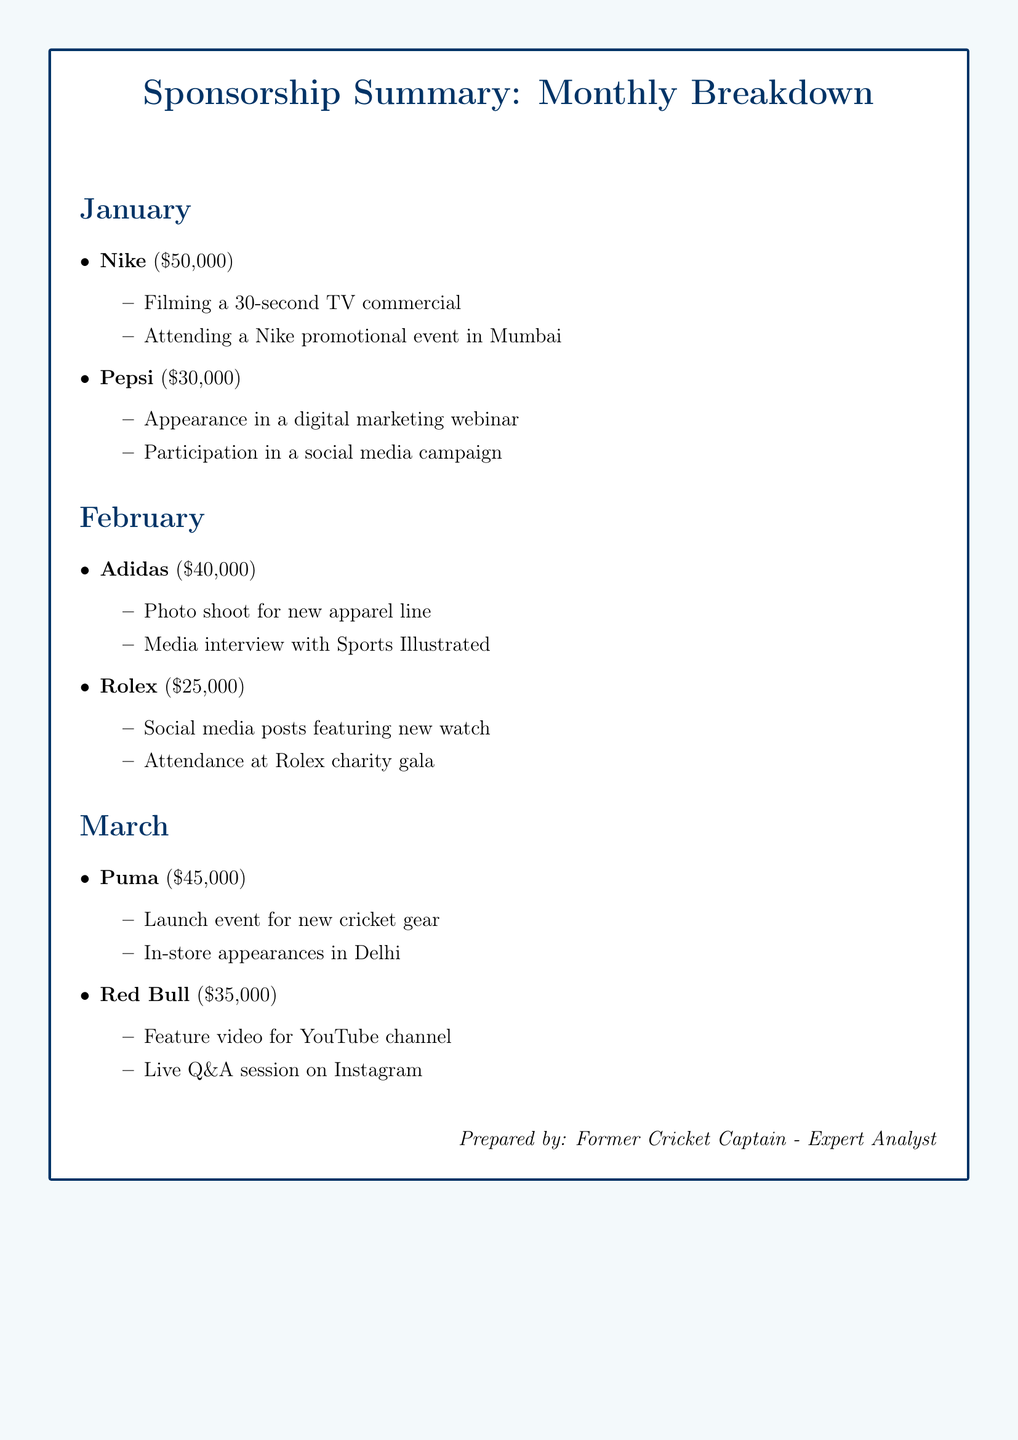What is the sponsorship amount from Nike in January? The document states that Nike's sponsorship amount in January is \$50,000.
Answer: \$50,000 Which company had endorsements worth \$40,000 in February? According to the document, Adidas had endorsements worth \$40,000 in February.
Answer: Adidas How many events did Pepsi sponsor in January? The document mentions two events sponsored by Pepsi in January: a digital marketing webinar and a social media campaign.
Answer: 2 What was the total endorsement income for March? The total for March is calculated as \$45,000 (Puma) + \$35,000 (Red Bull) = \$80,000.
Answer: \$80,000 What type of event did Rolex sponsor in February? The document mentions that Rolex sponsored a charity gala in February.
Answer: Charity gala Which months featured Puma as a sponsor? Puma is listed as a sponsor only in March according to the document.
Answer: March What was the main activity listed for Adidas in February? The key activity listed for Adidas is a photo shoot for a new apparel line.
Answer: Photo shoot How many companies are mentioned in the January section? The January section mentions two companies: Nike and Pepsi.
Answer: 2 